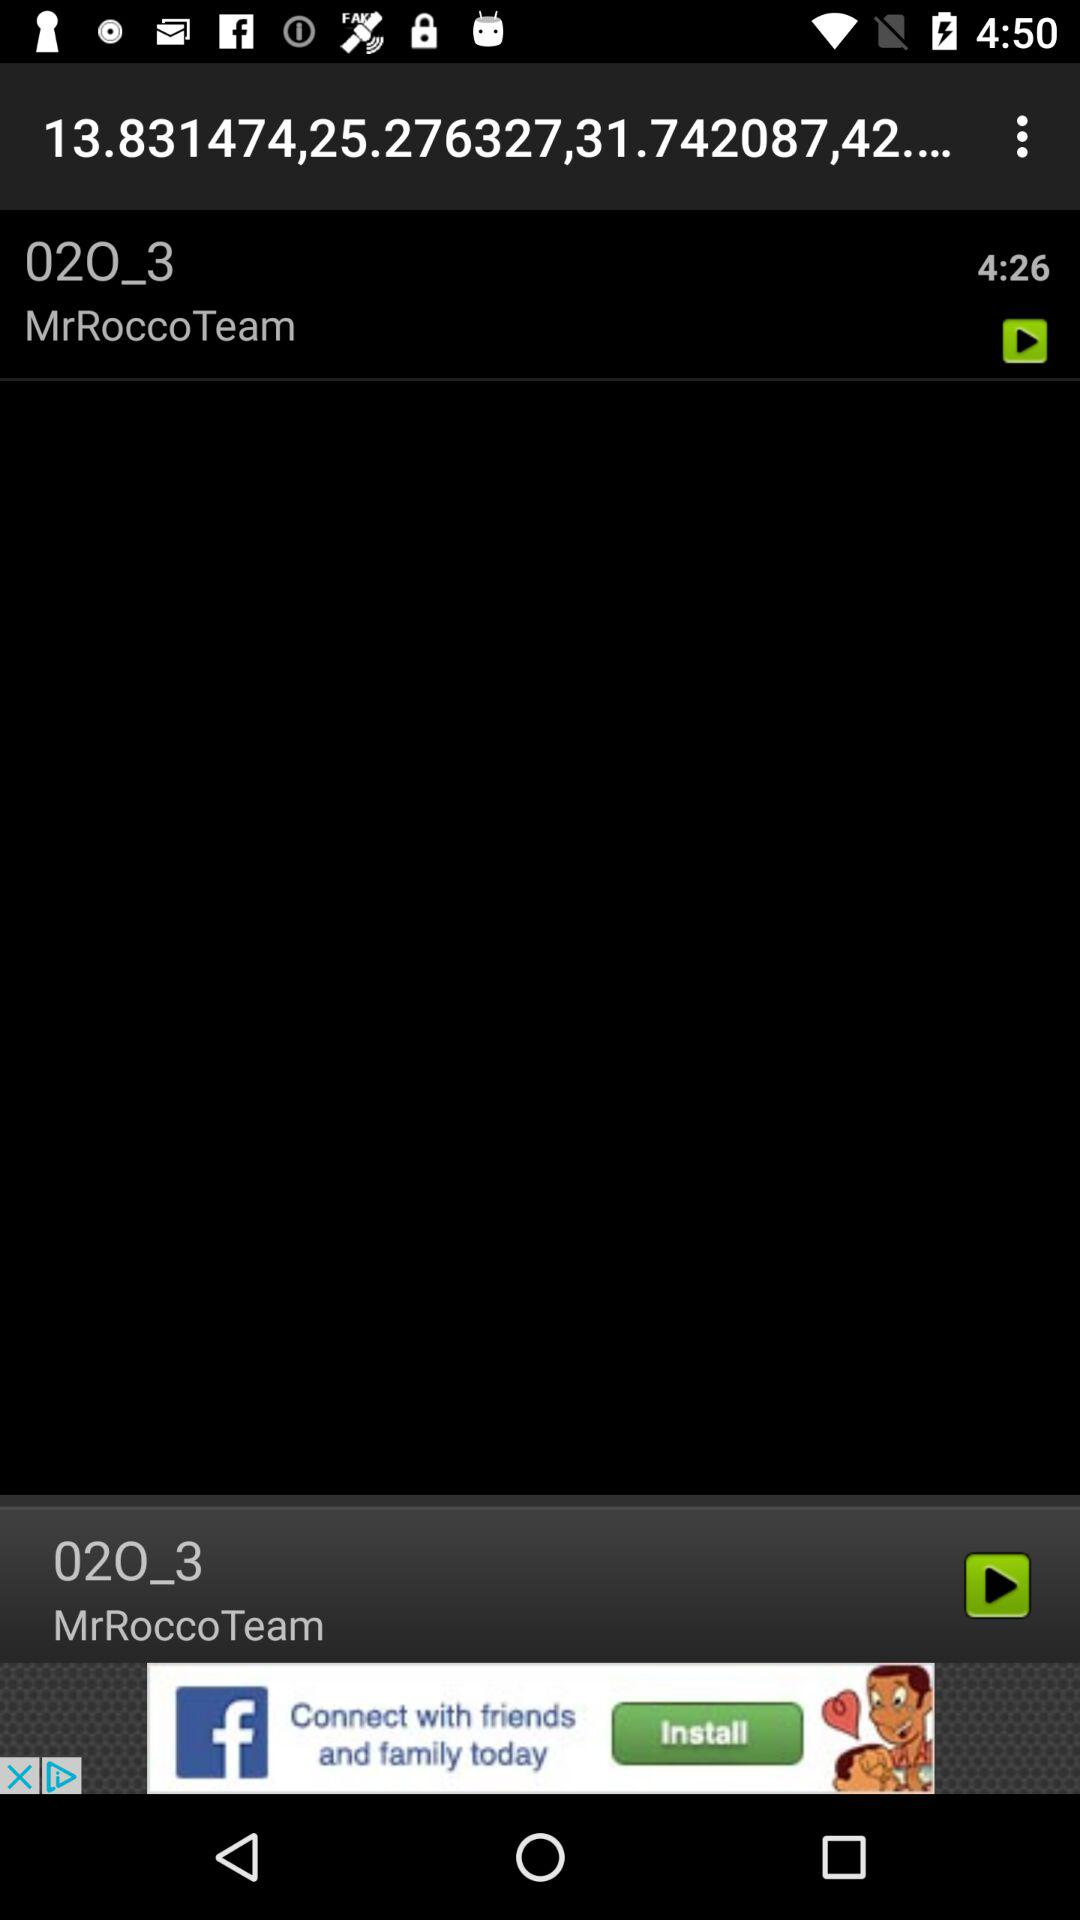What is the time duration of the song? The time duration of the song is 4 minutes and 26 seconds. 